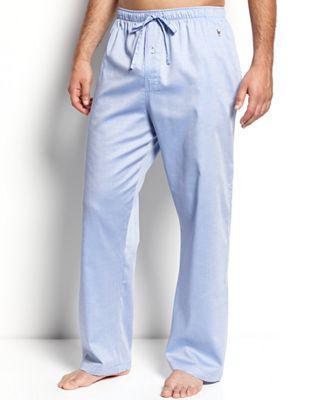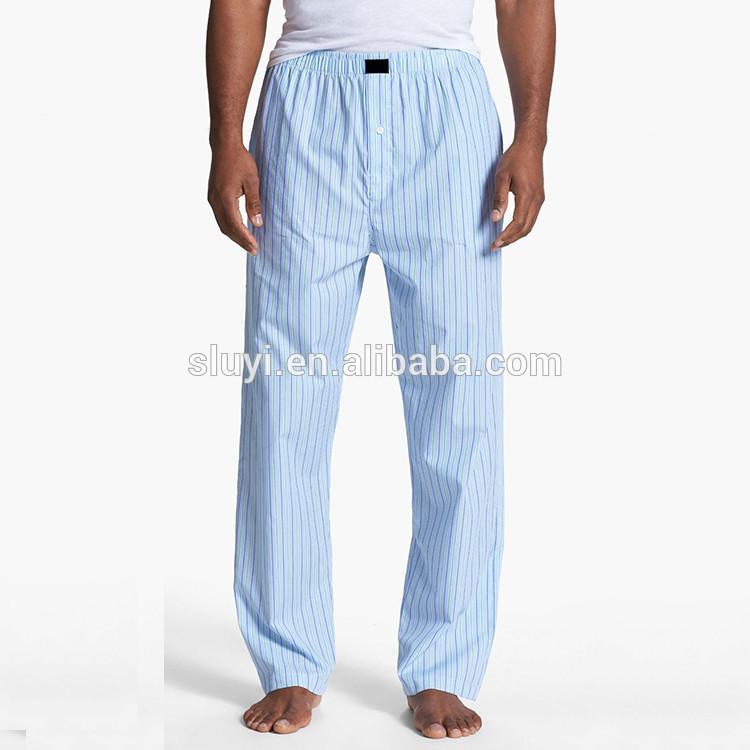The first image is the image on the left, the second image is the image on the right. Given the left and right images, does the statement "There are two pairs of grey athletic pants." hold true? Answer yes or no. No. 